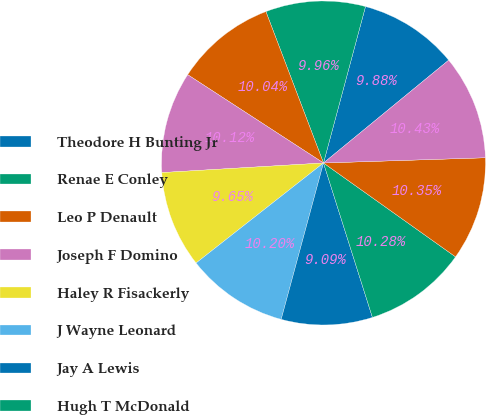Convert chart. <chart><loc_0><loc_0><loc_500><loc_500><pie_chart><fcel>Theodore H Bunting Jr<fcel>Renae E Conley<fcel>Leo P Denault<fcel>Joseph F Domino<fcel>Haley R Fisackerly<fcel>J Wayne Leonard<fcel>Jay A Lewis<fcel>Hugh T McDonald<fcel>Carolyn C Shanks<fcel>Richard J Smith<nl><fcel>9.88%<fcel>9.96%<fcel>10.04%<fcel>10.12%<fcel>9.65%<fcel>10.2%<fcel>9.09%<fcel>10.28%<fcel>10.35%<fcel>10.43%<nl></chart> 